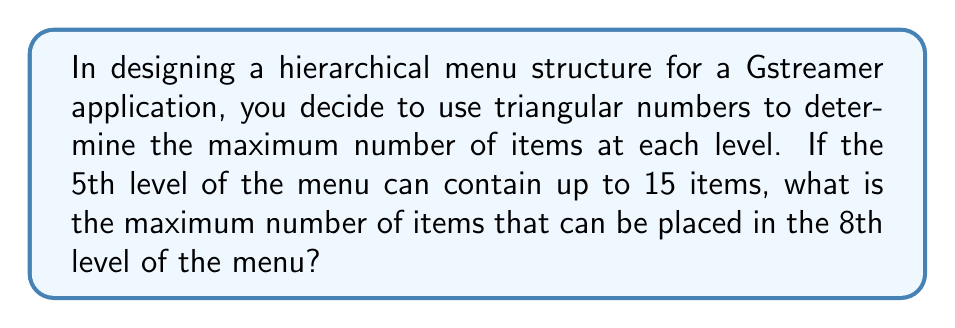Provide a solution to this math problem. Let's approach this step-by-step:

1) Triangular numbers follow the sequence: 1, 3, 6, 10, 15, 21, 28, 36, ...

2) The nth triangular number is given by the formula:

   $$T_n = \frac{n(n+1)}{2}$$

3) We're told that the 5th level has 15 items. Let's verify this:

   $$T_5 = \frac{5(5+1)}{2} = \frac{5(6)}{2} = \frac{30}{2} = 15$$

4) Now, we need to find the 8th triangular number. Let's use the formula:

   $$T_8 = \frac{8(8+1)}{2} = \frac{8(9)}{2} = \frac{72}{2} = 36$$

5) Therefore, the 8th level of the menu can contain up to 36 items.
Answer: 36 